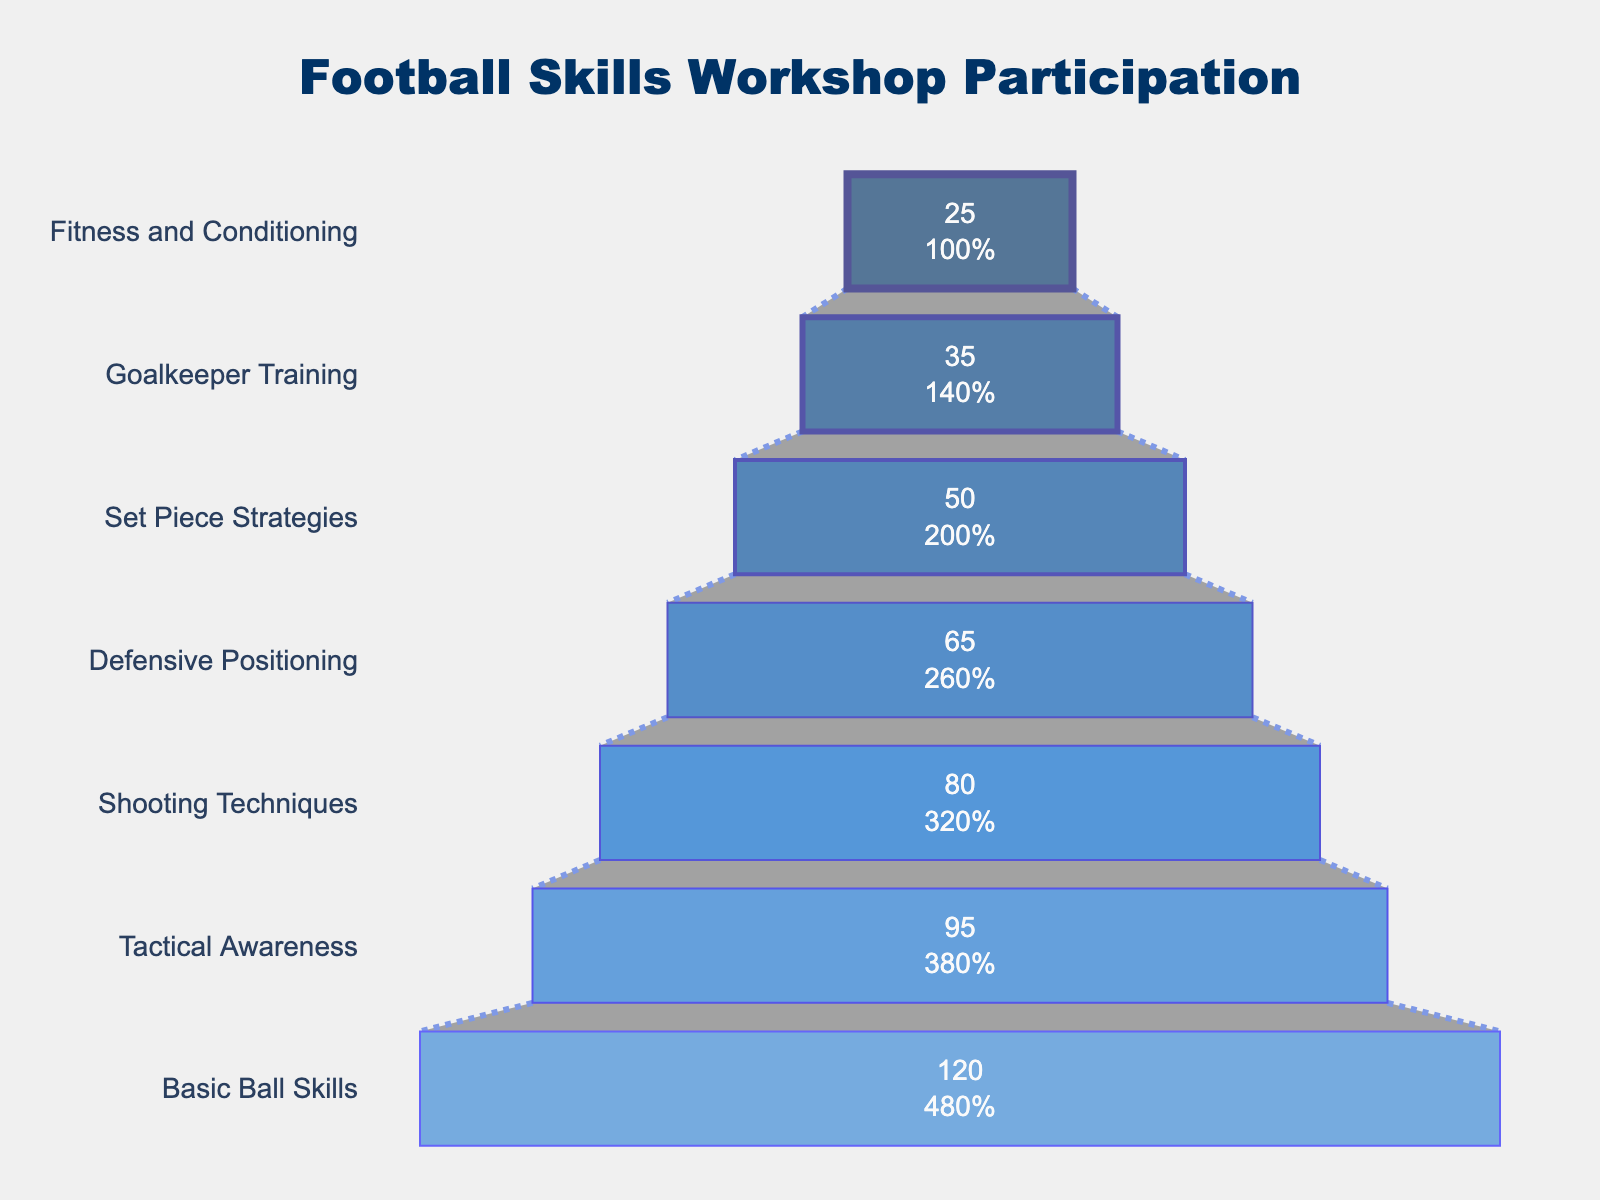What's the title of the chart? The title is typically located at the top center of the chart. For this chart, it reads "Football Skills Workshop Participation," which distinctly outlines what the chart is about.
Answer: Football Skills Workshop Participation How many workshops have participation above 70? By examining the funnel chart, workshops with participation above 70 are highlighted near the wider section. Workshops that surpass this threshold include "Basic Ball Skills," "Tactical Awareness," and "Shooting Techniques."
Answer: 3 What is the least attended workshop? The funnel chart narrows significantly at the bottom, where the least participation is shown. The workshop at the bottom is "Fitness and Conditioning."
Answer: Fitness and Conditioning Which workshop has the second highest number of participants? After the widest part representing the highest participation, the funnel slightly narrows. The segment in this position is "Tactical Awareness" with 95 participants.
Answer: Tactical Awareness What's the difference in participation between the "Set Piece Strategies" and "Goalkeeper Training" workshops? By locating both workshops in the funnel chart, we can see "Set Piece Strategies" has 50 participants and "Goalkeeper Training" has 35. The difference is calculated by subtracting 35 from 50.
Answer: 15 How many more participants did "Basic Ball Skills" have compared to "Defensive Positioning"? "Basic Ball Skills" is at the top with 120 participants, while "Defensive Positioning" sits at 65 in the funnel chart. The difference is 120 minus 65.
Answer: 55 What percent of the initial participants attended "Shooting Techniques"? "Shooting Techniques" has 80 participants. To find the percentage, (80/120) * 100%.
Answer: 66.67% Which workshops have fewer than 50 participants? Workshops that fall towards the narrower end of the funnel have fewer than 50 participants. They are "Goalkeeper Training" and "Fitness and Conditioning."
Answer: 2 What is the total participation for all workshops combined? Summing up all participant numbers from the chart: 120 + 95 + 80 + 65 + 50 + 35 + 25.
Answer: 470 What workshops appear between "Tactical Awareness" and "Goalkeeper Training" in terms of participation levels? Referring to the sequence in the funnel from widest to narrowest, between "Tactical Awareness" and "Goalkeeper Training" are "Shooting Techniques," "Defensive Positioning," and "Set Piece Strategies."
Answer: Shooting Techniques, Defensive Positioning, Set Piece Strategies 